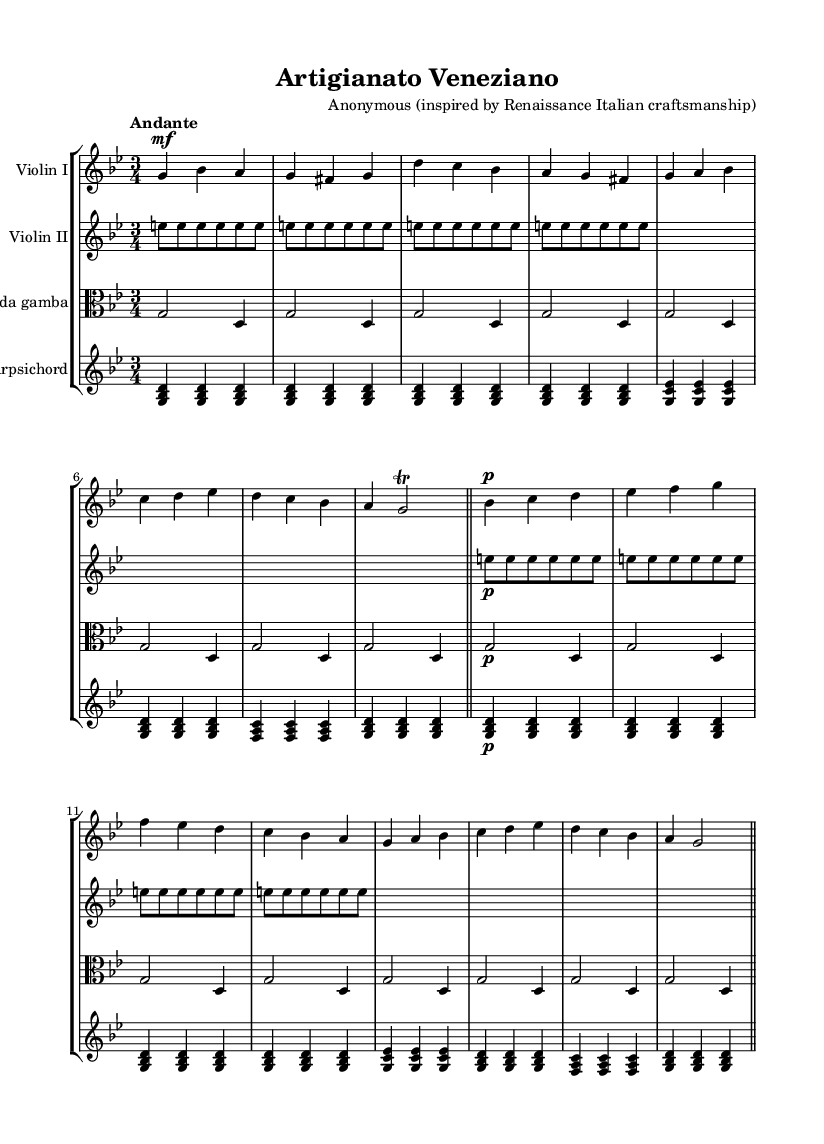What is the key signature of this music? The key signature is indicated at the beginning of the staff. Looking at the key signature symbol, we see that it has two flats, which corresponds to the key of G minor.
Answer: G minor What is the time signature of this music? The time signature is placed at the beginning of the music notation, right after the key signature. It shows "3/4," indicating three beats in every measure and a quarter note gets one beat.
Answer: 3/4 What is the tempo marking of this piece? The tempo marking is usually noted above the staff and indicates the speed of the piece. Here, it states "Andante," suggesting a moderate walking pace.
Answer: Andante How many measures are in the first section? To find the number of measures, we count the number of vertical lines (bar lines) that separate the measures in the first section until the double bar line. The first section ends with a double bar after 8 measures.
Answer: 8 What instruments are included in this chamber music arrangement? The instruments are usually labeled at the beginning of each staff. Here, we have "Violin I," "Violin II," "Viola da gamba," and "Harpsichord" labeled clearly.
Answer: Violin I, Violin II, Viola da gamba, Harpsichord What type of music form is typical in Baroque chamber music, as observed in this piece? Examining the interaction among the instruments and the structure of the parts, we observe the use of counterpoint, where each instrument plays a distinct melodic line that harmonizes with others, a common characteristic of Baroque music.
Answer: Counterpoint What dynamic marking is used for the first violin part in the second section? The dynamic marking indicates how loud or soft the music should be played. In the second section of the first violin part, it shows "p," which means pianissimo, indicating a soft sound.
Answer: pianissimo 